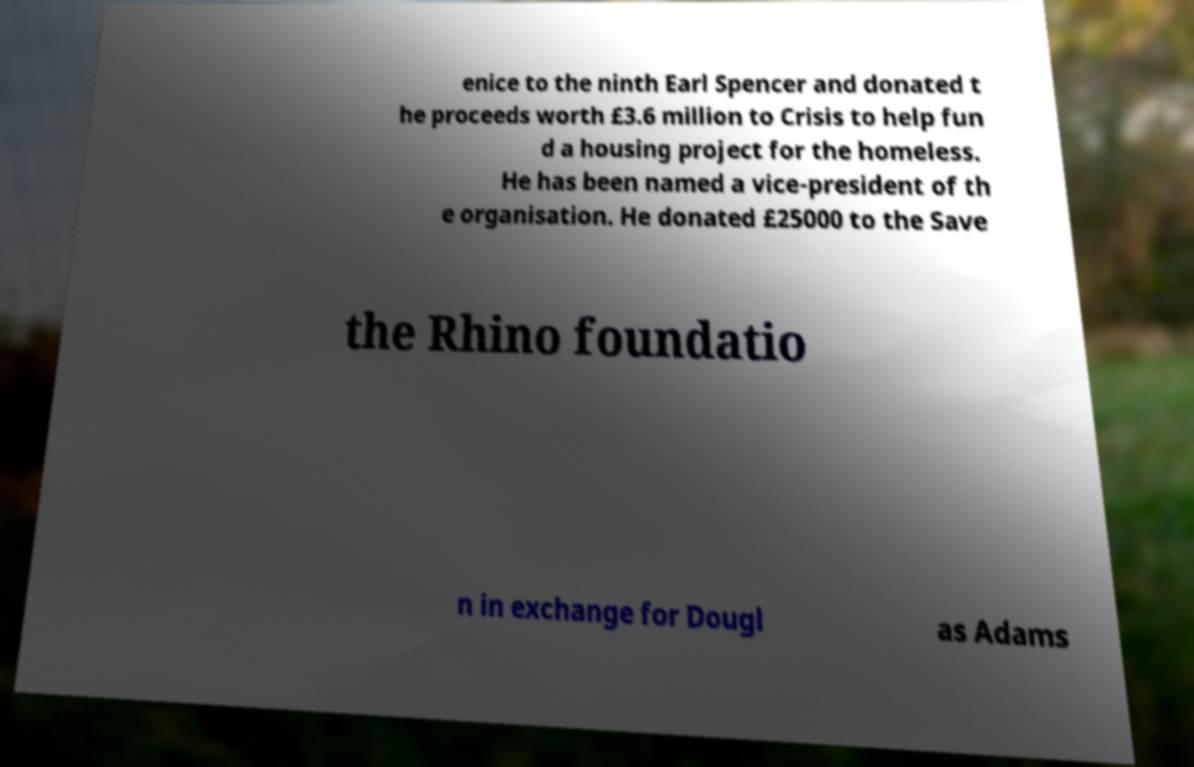Please identify and transcribe the text found in this image. enice to the ninth Earl Spencer and donated t he proceeds worth £3.6 million to Crisis to help fun d a housing project for the homeless. He has been named a vice-president of th e organisation. He donated £25000 to the Save the Rhino foundatio n in exchange for Dougl as Adams 